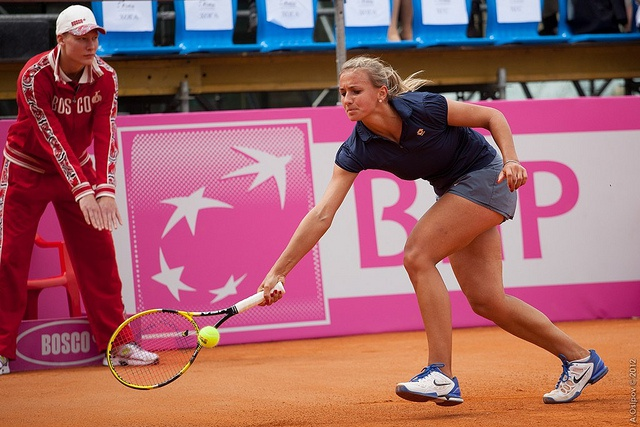Describe the objects in this image and their specific colors. I can see people in maroon, black, and brown tones, people in maroon, brown, and lightpink tones, tennis racket in maroon, salmon, and brown tones, chair in maroon, purple, and brown tones, and sports ball in maroon, khaki, orange, and yellow tones in this image. 